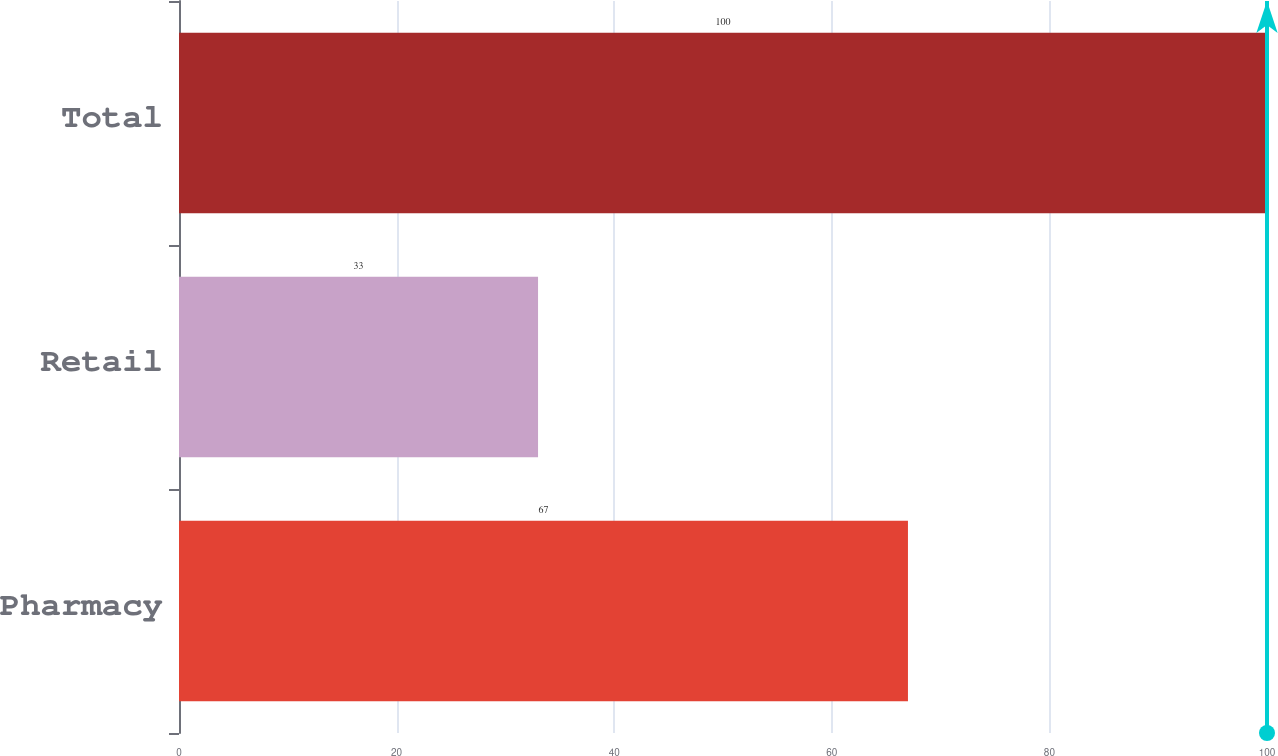Convert chart to OTSL. <chart><loc_0><loc_0><loc_500><loc_500><bar_chart><fcel>Pharmacy<fcel>Retail<fcel>Total<nl><fcel>67<fcel>33<fcel>100<nl></chart> 